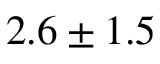Convert formula to latex. <formula><loc_0><loc_0><loc_500><loc_500>2 . 6 \pm 1 . 5</formula> 